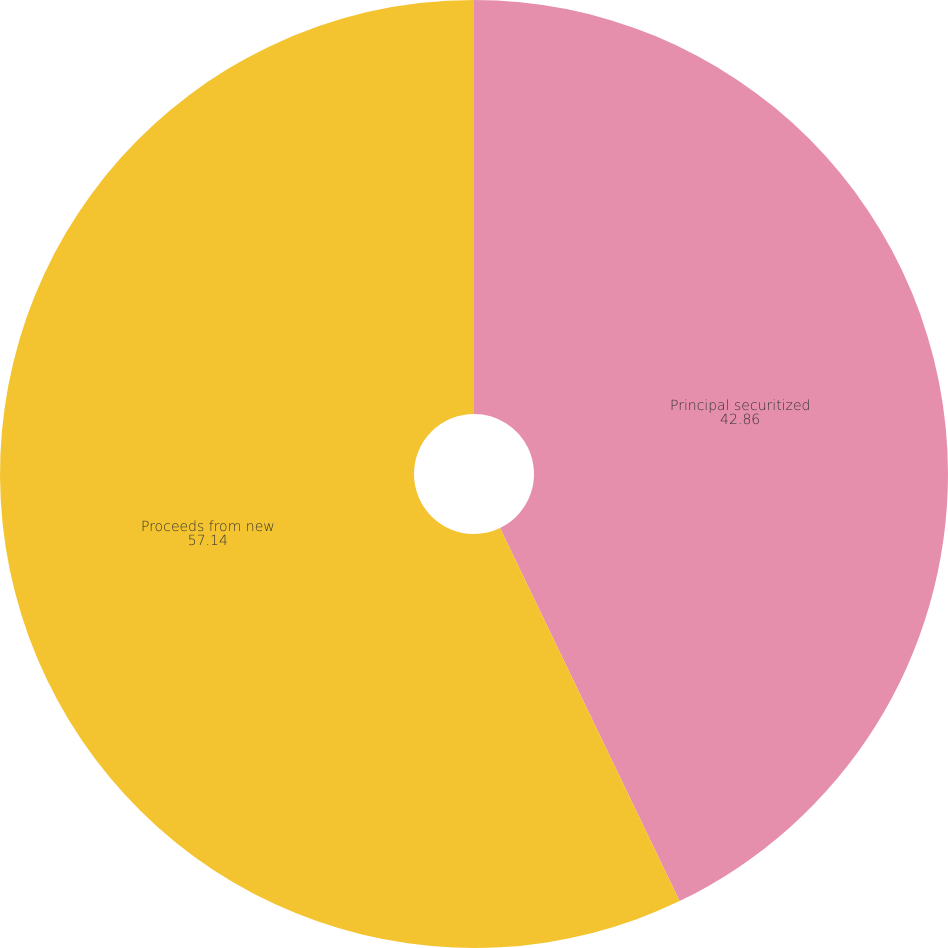Convert chart to OTSL. <chart><loc_0><loc_0><loc_500><loc_500><pie_chart><fcel>Principal securitized<fcel>Proceeds from new<nl><fcel>42.86%<fcel>57.14%<nl></chart> 